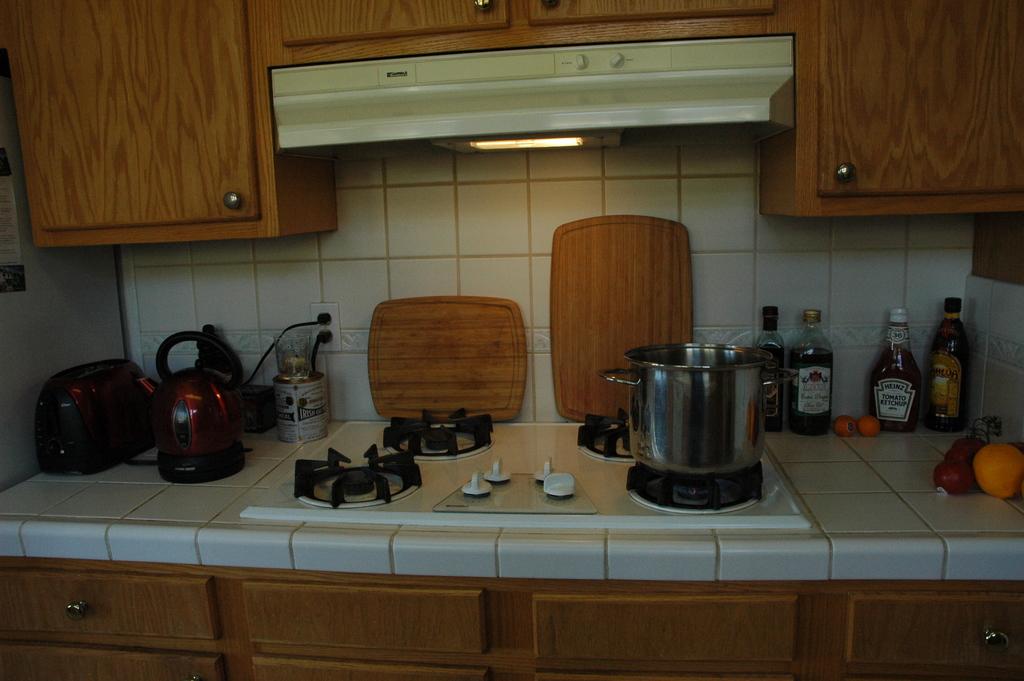What type of oil is on the counter?
Provide a short and direct response. Olive. What brand of ketchup is on the counter?
Ensure brevity in your answer.  Heinz. 